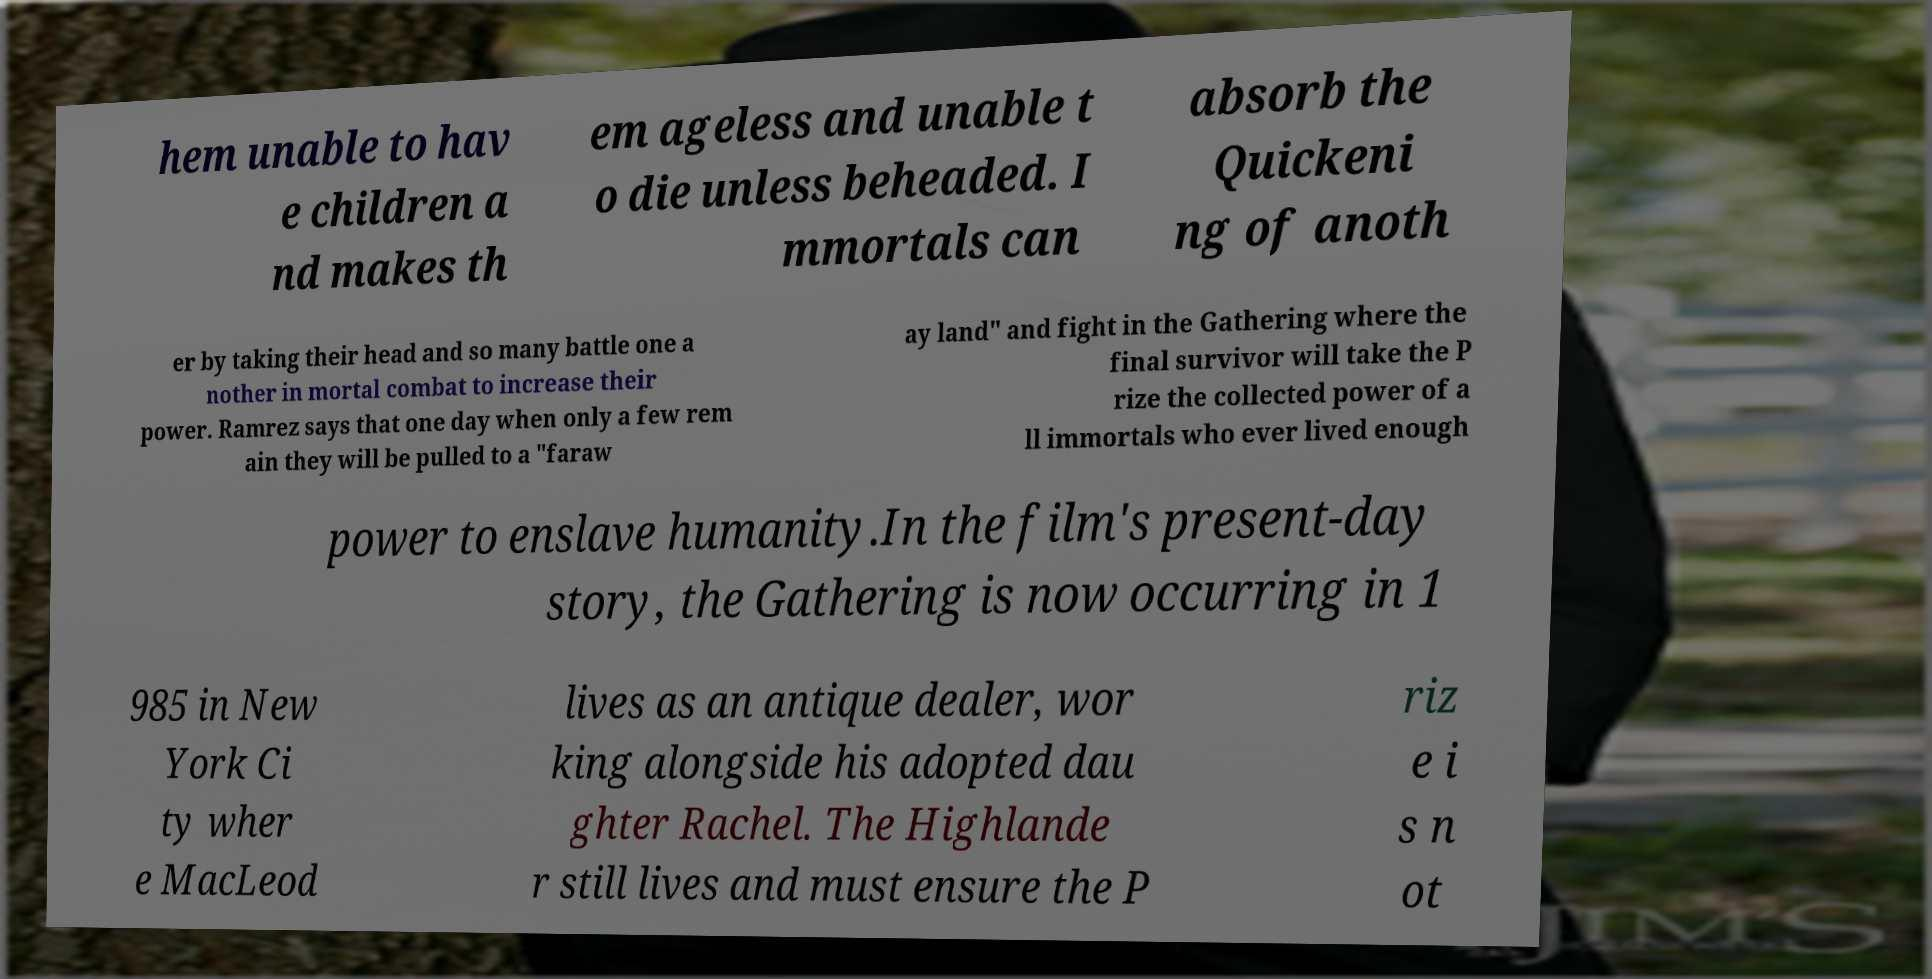Can you read and provide the text displayed in the image?This photo seems to have some interesting text. Can you extract and type it out for me? hem unable to hav e children a nd makes th em ageless and unable t o die unless beheaded. I mmortals can absorb the Quickeni ng of anoth er by taking their head and so many battle one a nother in mortal combat to increase their power. Ramrez says that one day when only a few rem ain they will be pulled to a "faraw ay land" and fight in the Gathering where the final survivor will take the P rize the collected power of a ll immortals who ever lived enough power to enslave humanity.In the film's present-day story, the Gathering is now occurring in 1 985 in New York Ci ty wher e MacLeod lives as an antique dealer, wor king alongside his adopted dau ghter Rachel. The Highlande r still lives and must ensure the P riz e i s n ot 